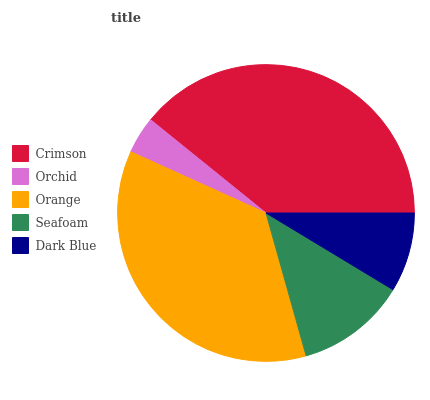Is Orchid the minimum?
Answer yes or no. Yes. Is Crimson the maximum?
Answer yes or no. Yes. Is Orange the minimum?
Answer yes or no. No. Is Orange the maximum?
Answer yes or no. No. Is Orange greater than Orchid?
Answer yes or no. Yes. Is Orchid less than Orange?
Answer yes or no. Yes. Is Orchid greater than Orange?
Answer yes or no. No. Is Orange less than Orchid?
Answer yes or no. No. Is Seafoam the high median?
Answer yes or no. Yes. Is Seafoam the low median?
Answer yes or no. Yes. Is Orange the high median?
Answer yes or no. No. Is Crimson the low median?
Answer yes or no. No. 